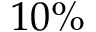<formula> <loc_0><loc_0><loc_500><loc_500>1 0 \%</formula> 